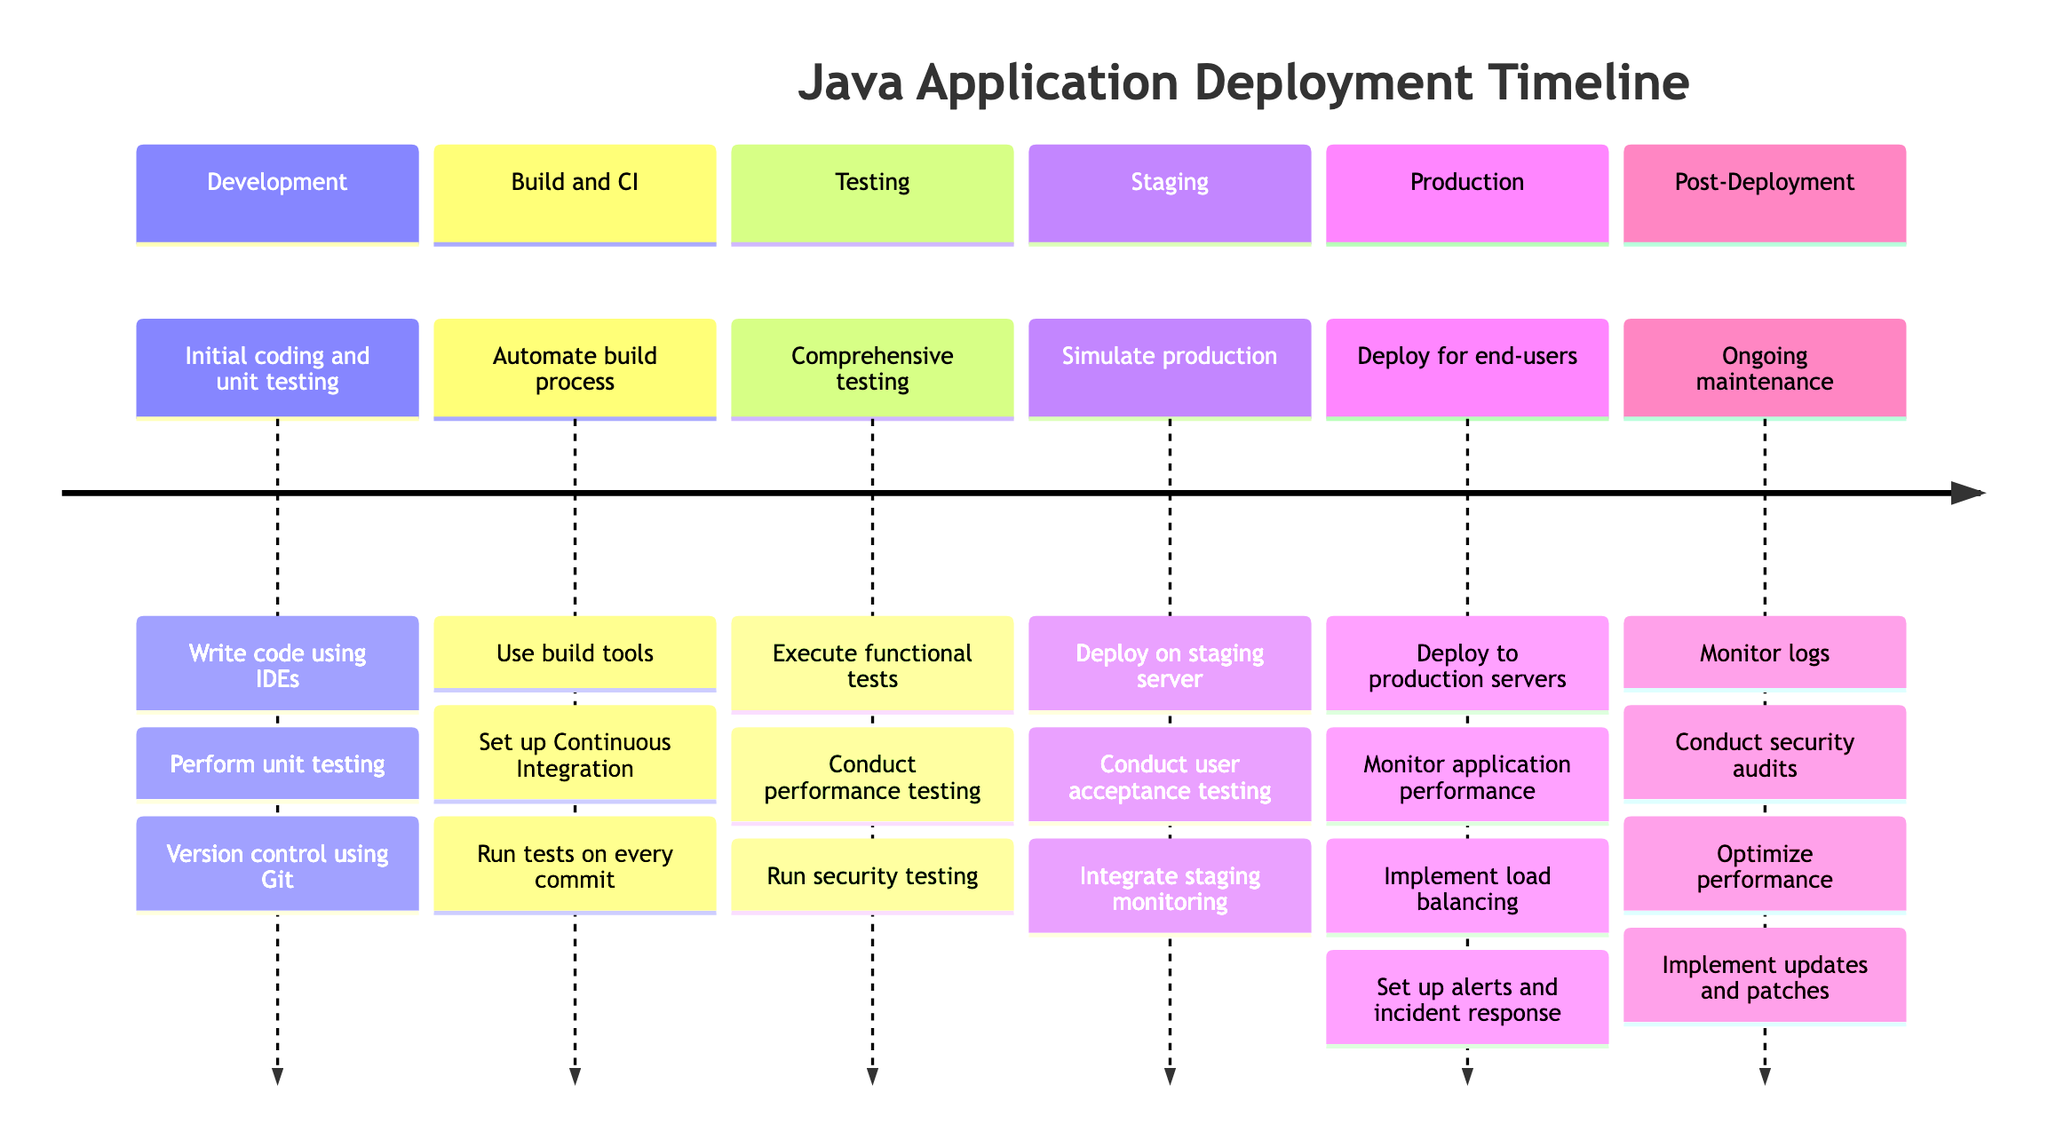What is the first stage in the deployment timeline? The timeline starts with the "Development" stage, which is the initial phase before any deployment occurs.
Answer: Development How many tasks are listed under the "Production" stage? The "Production" stage lists four tasks, as indicated by the tasks that follow it in the timeline.
Answer: 4 What is the main focus of the "Testing" stage? The "Testing" stage emphasizes comprehensive testing to identify and fix bugs, as described in its description.
Answer: Comprehensive testing Which stage follows "Staging"? The "Production" stage comes after "Staging", implying the flow of the deployment process from one stage to the next.
Answer: Production What tool is suggested for monitoring application performance in the "Production" stage? The timeline specifies "New Relic" or "Grafana" as tools for monitoring application performance during the "Production" stage.
Answer: New Relic or Grafana How many total stages are outlined in the diagram? There are six stages outlined in the deployment timeline, counting each stage individually shown in the diagram.
Answer: 6 What is a task mentioned under the "Post-Deployment" stage? One of the tasks listed under "Post-Deployment" is "Monitor logs," which is essential for ongoing maintenance.
Answer: Monitor logs What type of testing is performed during the "Staging" stage? User acceptance testing (UAT) is conducted in the "Staging" stage, indicating that the application is tested from the end-user perspective.
Answer: User acceptance testing Which stage includes running security testing? The "Testing" stage includes running security testing as one of its core tasks, aimed at ensuring the application's security posture.
Answer: Testing 